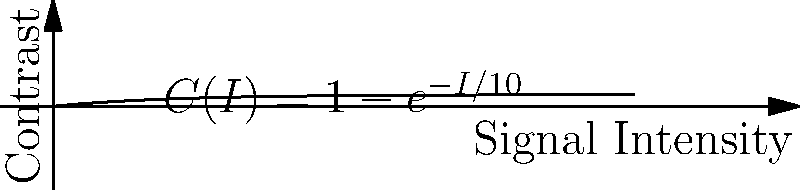In fMRI imaging, the contrast $C$ as a function of signal intensity $I$ is given by the equation $C(I) = 1 - e^{-I/10}$, where $I$ is measured in arbitrary units. At what signal intensity does the rate of change of contrast with respect to signal intensity equal 0.05 units of contrast per unit of signal intensity? To solve this problem, we need to follow these steps:

1) First, we need to find the derivative of $C(I)$ with respect to $I$:
   $$\frac{dC}{dI} = \frac{d}{dI}(1 - e^{-I/10}) = \frac{1}{10}e^{-I/10}$$

2) We want to find the value of $I$ where this derivative equals 0.05:
   $$\frac{1}{10}e^{-I/10} = 0.05$$

3) Multiply both sides by 10:
   $$e^{-I/10} = 0.5$$

4) Take the natural logarithm of both sides:
   $$-I/10 = \ln(0.5)$$

5) Multiply both sides by -10:
   $$I = -10\ln(0.5)$$

6) Calculate the final value:
   $$I = -10 * (-0.69314718) \approx 6.93$$

Therefore, the rate of change of contrast with respect to signal intensity equals 0.05 units of contrast per unit of signal intensity when the signal intensity is approximately 6.93 arbitrary units.
Answer: 6.93 arbitrary units 